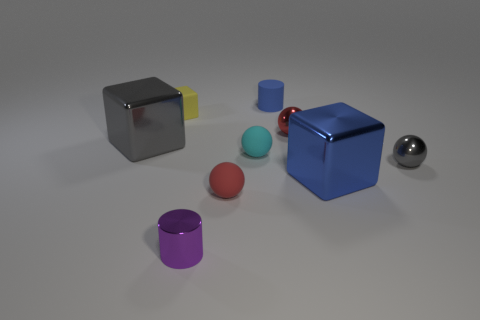Which object stands out most to you and why? The blue cube stands out because of its bright, saturated color and its central placement amongst the other objects in the image. Does the positioning of these objects suggest anything to you? The arrangement seems deliberate, almost like a minimalist art installation, with a balance of shapes and colors that draws the eye around the scene. 